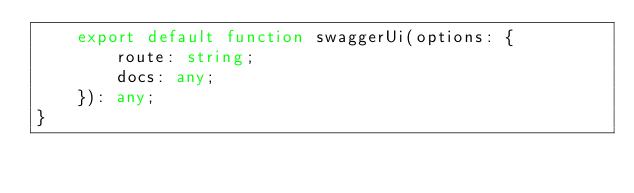Convert code to text. <code><loc_0><loc_0><loc_500><loc_500><_TypeScript_>    export default function swaggerUi(options: {
        route: string;
        docs: any;
    }): any;
}</code> 